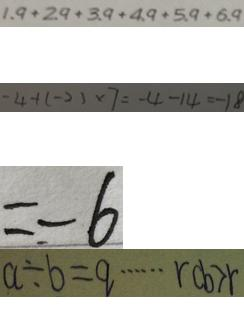<formula> <loc_0><loc_0><loc_500><loc_500>1 . 9 + 2 . 9 + 3 . 9 + 4 . 9 + 5 . 9 + 6 . 9 
 - 4 + ( - 2 ) \times 7 = - 4 - 1 4 = - 1 8 
 = - 6 
 a \div b = q \cdots r c b > r</formula> 